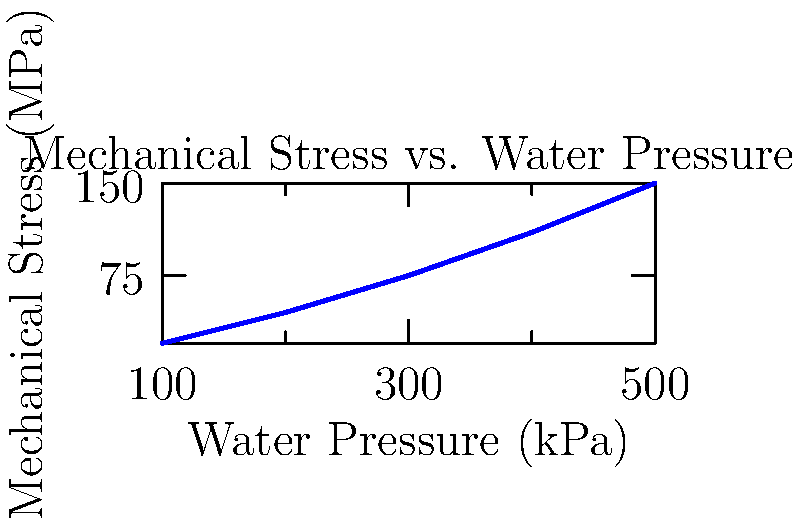Based on the graph showing the relationship between water pressure and mechanical stress on filtration membranes, what is the approximate rate of increase in mechanical stress (in MPa) for every 100 kPa increase in water pressure? To determine the rate of increase in mechanical stress per 100 kPa increase in water pressure, we can follow these steps:

1. Identify two points on the graph:
   - At 100 kPa: Stress ≈ 20 MPa
   - At 500 kPa: Stress ≈ 150 MPa

2. Calculate the total change in stress:
   $\Delta \text{Stress} = 150 \text{ MPa} - 20 \text{ MPa} = 130 \text{ MPa}$

3. Calculate the total change in pressure:
   $\Delta \text{Pressure} = 500 \text{ kPa} - 100 \text{ kPa} = 400 \text{ kPa}$

4. Calculate the rate of increase:
   $\text{Rate} = \frac{\Delta \text{Stress}}{\Delta \text{Pressure}} \times 100 \text{ kPa}$
   
   $\text{Rate} = \frac{130 \text{ MPa}}{400 \text{ kPa}} \times 100 \text{ kPa} = 32.5 \text{ MPa per 100 kPa}$

Therefore, the mechanical stress increases by approximately 32.5 MPa for every 100 kPa increase in water pressure.
Answer: 32.5 MPa per 100 kPa 